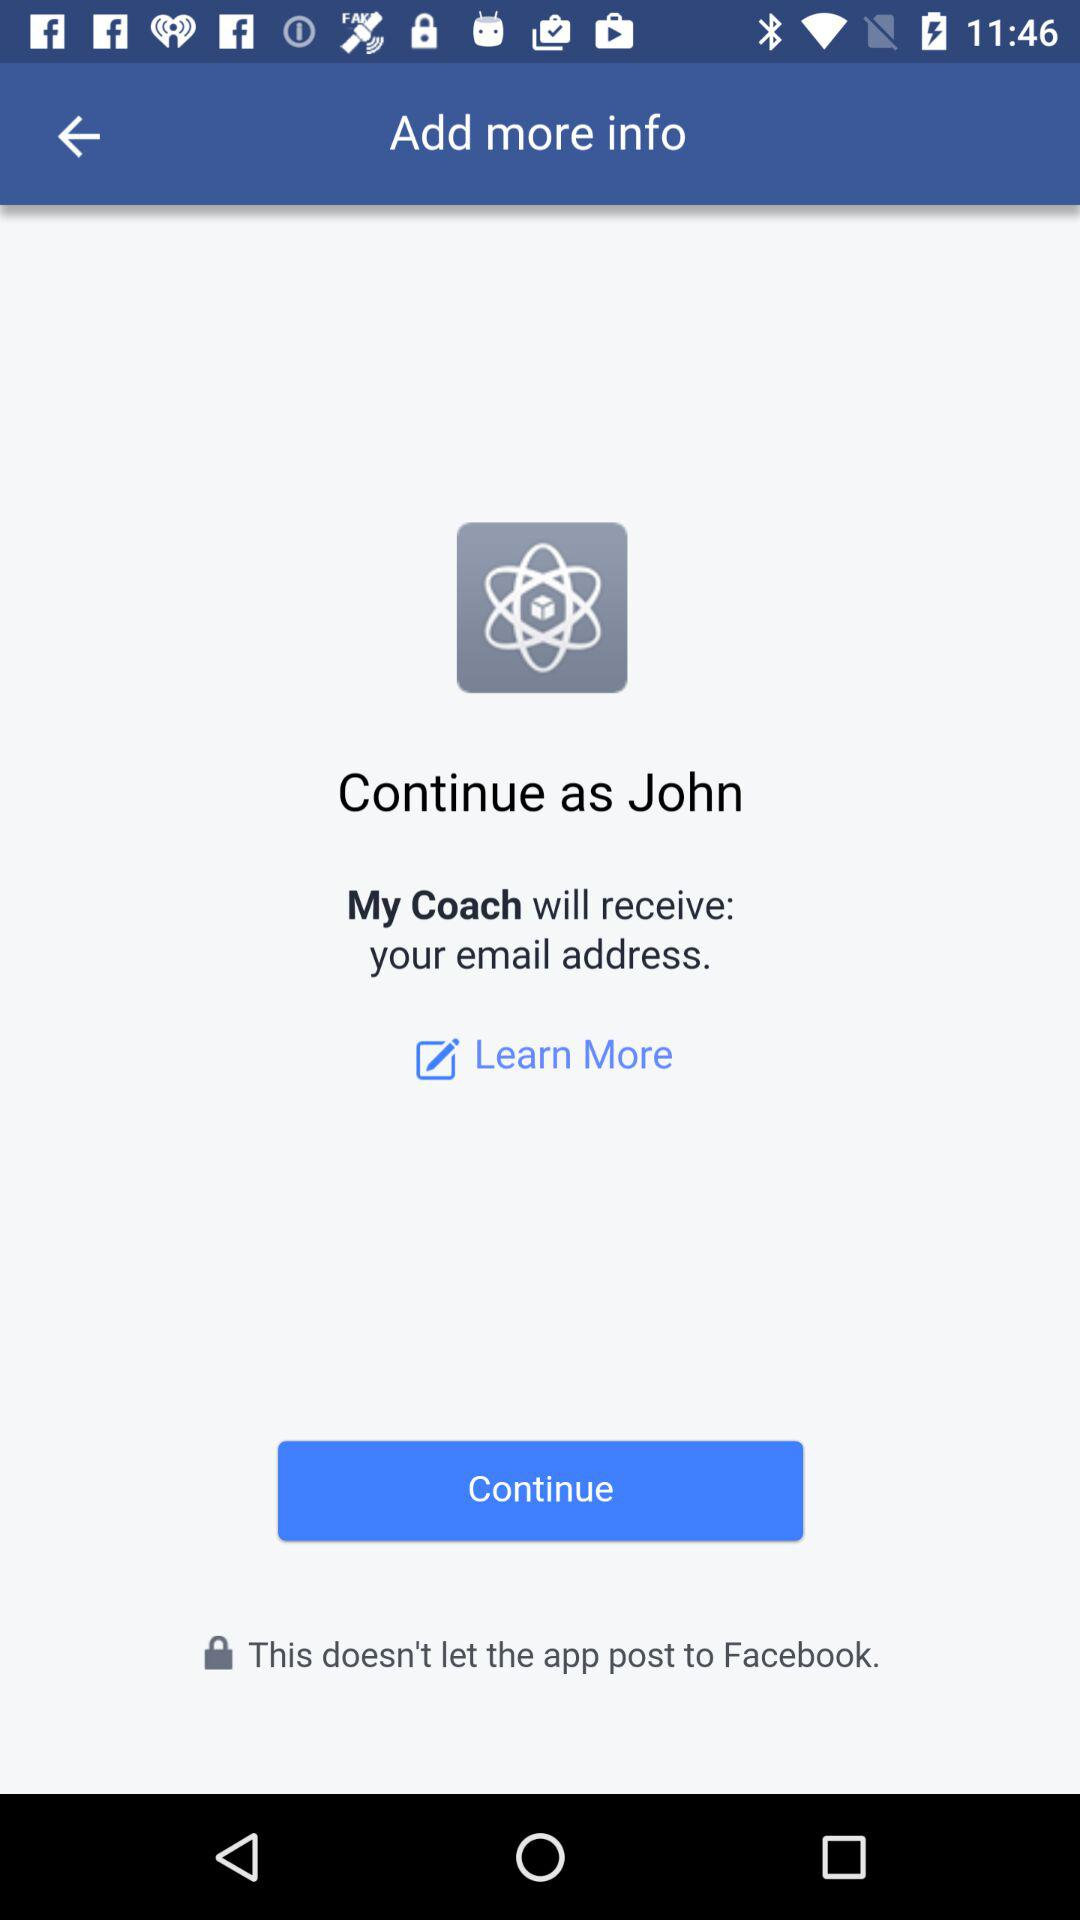What is the user name? The user name is "John". 